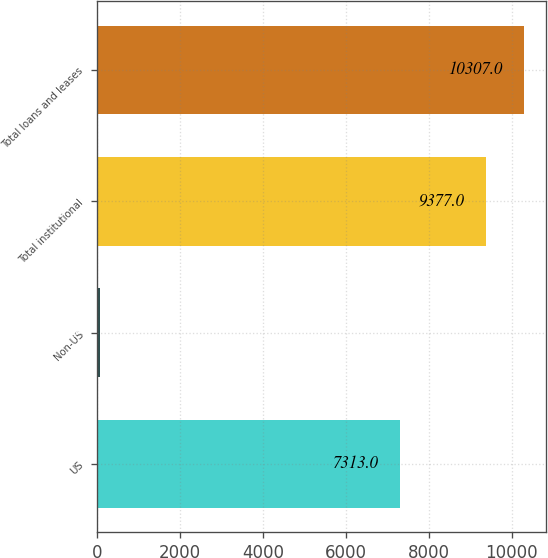<chart> <loc_0><loc_0><loc_500><loc_500><bar_chart><fcel>US<fcel>Non-US<fcel>Total institutional<fcel>Total loans and leases<nl><fcel>7313<fcel>77<fcel>9377<fcel>10307<nl></chart> 